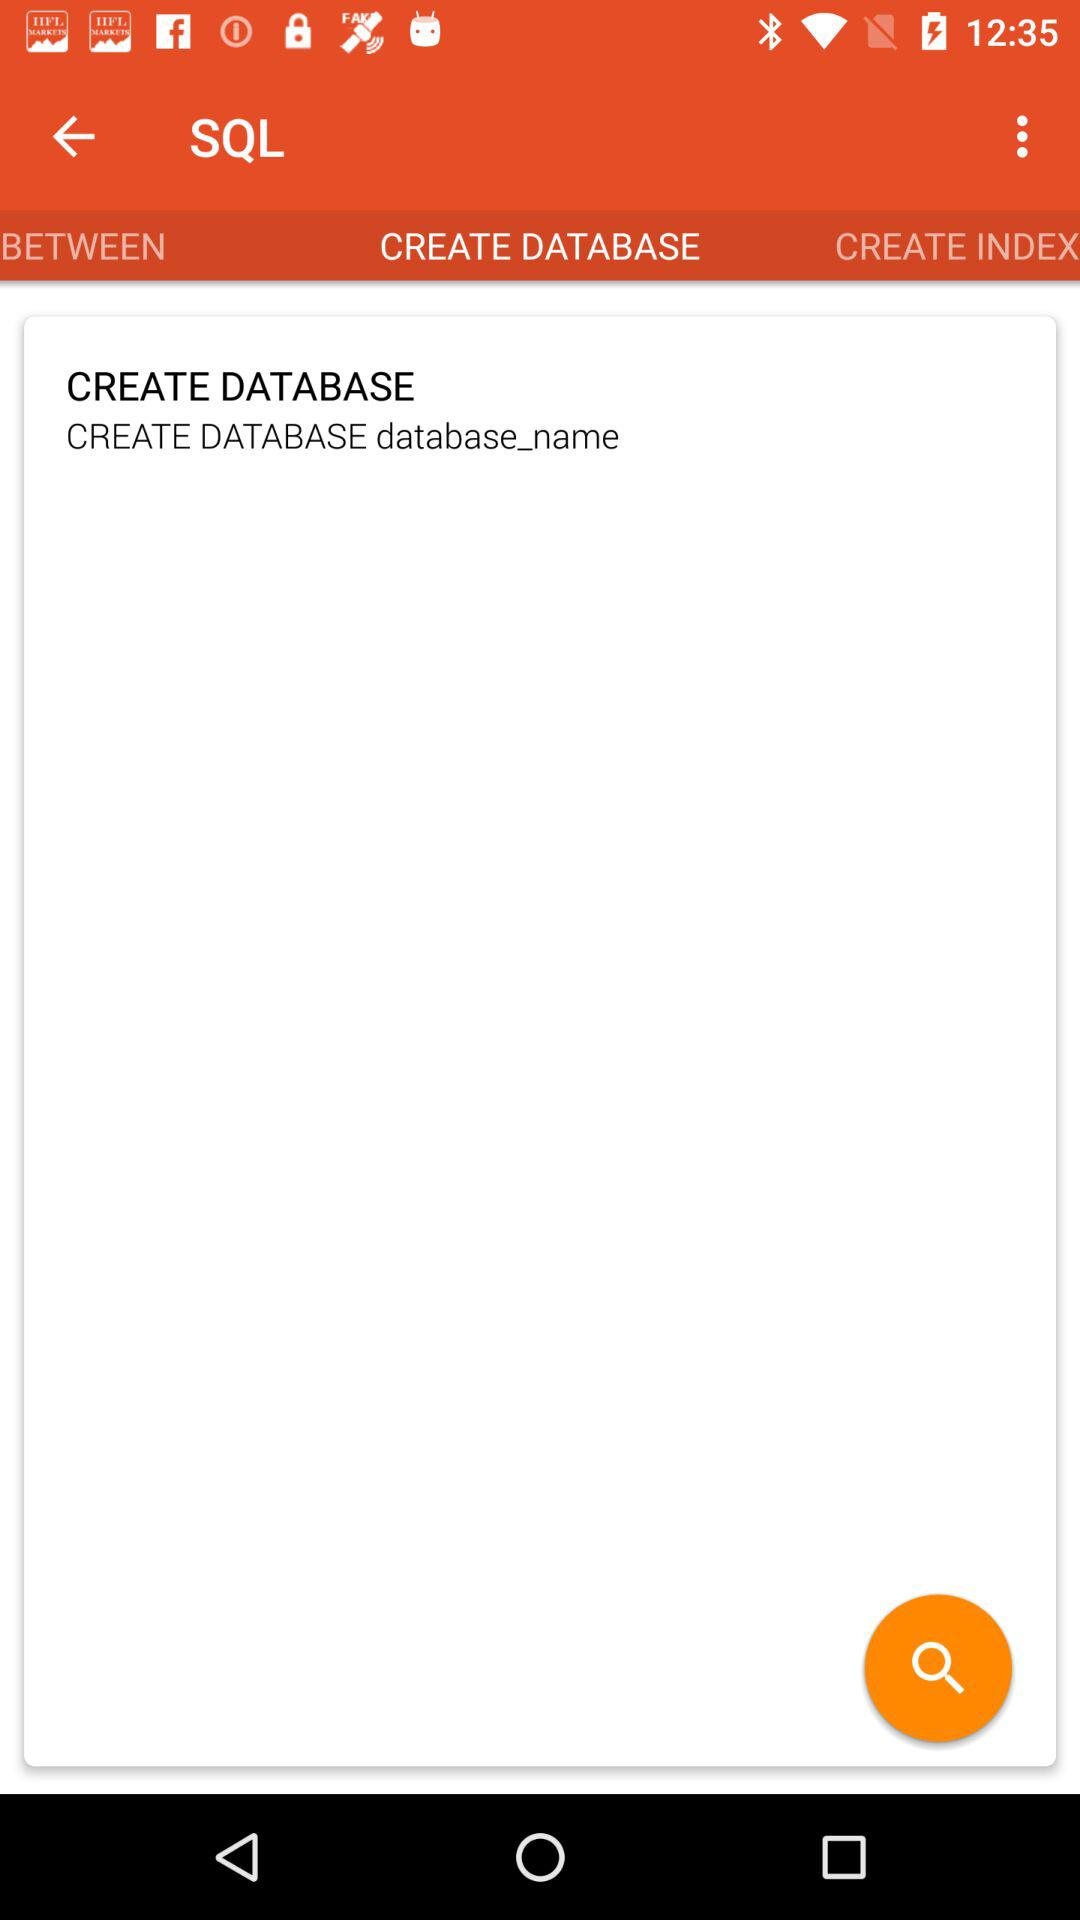Which tab is selected? The selected tab is "CREATE DATABASE". 